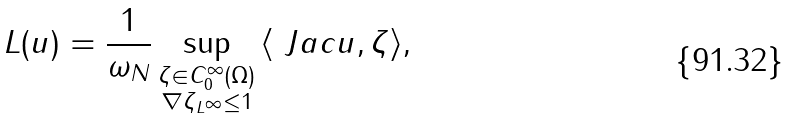Convert formula to latex. <formula><loc_0><loc_0><loc_500><loc_500>L ( u ) = \frac { 1 } { \omega _ { N } } \sup _ { \substack { \zeta \in C _ { 0 } ^ { \infty } ( \Omega ) \\ \| \nabla \zeta \| _ { L ^ { \infty } } \leq 1 } } { \langle \ J a c { u } , \zeta \rangle } ,</formula> 